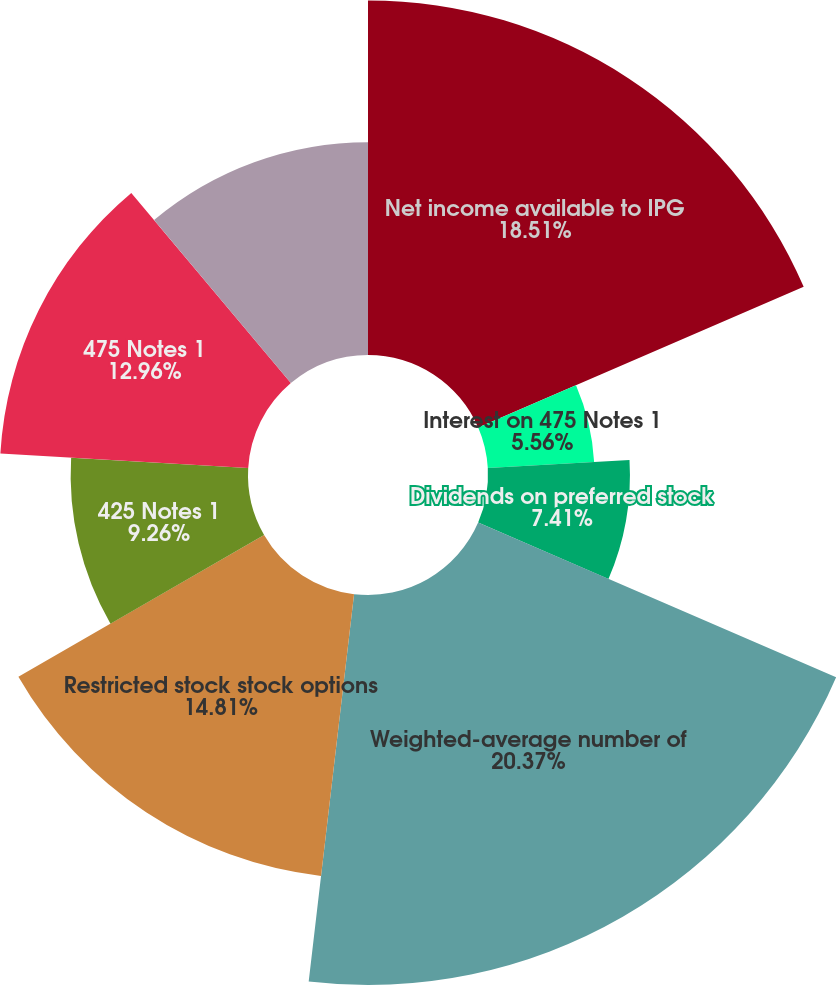Convert chart. <chart><loc_0><loc_0><loc_500><loc_500><pie_chart><fcel>Net income available to IPG<fcel>Interest on 425 Notes 1<fcel>Interest on 475 Notes 1<fcel>Dividends on preferred stock<fcel>Weighted-average number of<fcel>Restricted stock stock options<fcel>425 Notes 1<fcel>475 Notes 1<fcel>Preferred stock outstanding 2<nl><fcel>18.51%<fcel>0.01%<fcel>5.56%<fcel>7.41%<fcel>20.36%<fcel>14.81%<fcel>9.26%<fcel>12.96%<fcel>11.11%<nl></chart> 